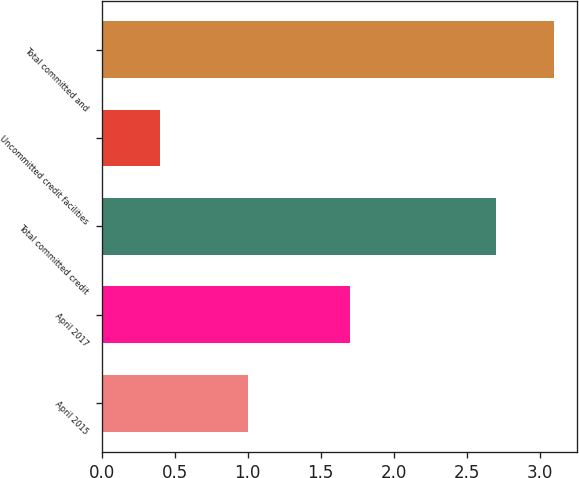Convert chart to OTSL. <chart><loc_0><loc_0><loc_500><loc_500><bar_chart><fcel>April 2015<fcel>April 2017<fcel>Total committed credit<fcel>Uncommitted credit facilities<fcel>Total committed and<nl><fcel>1<fcel>1.7<fcel>2.7<fcel>0.4<fcel>3.1<nl></chart> 